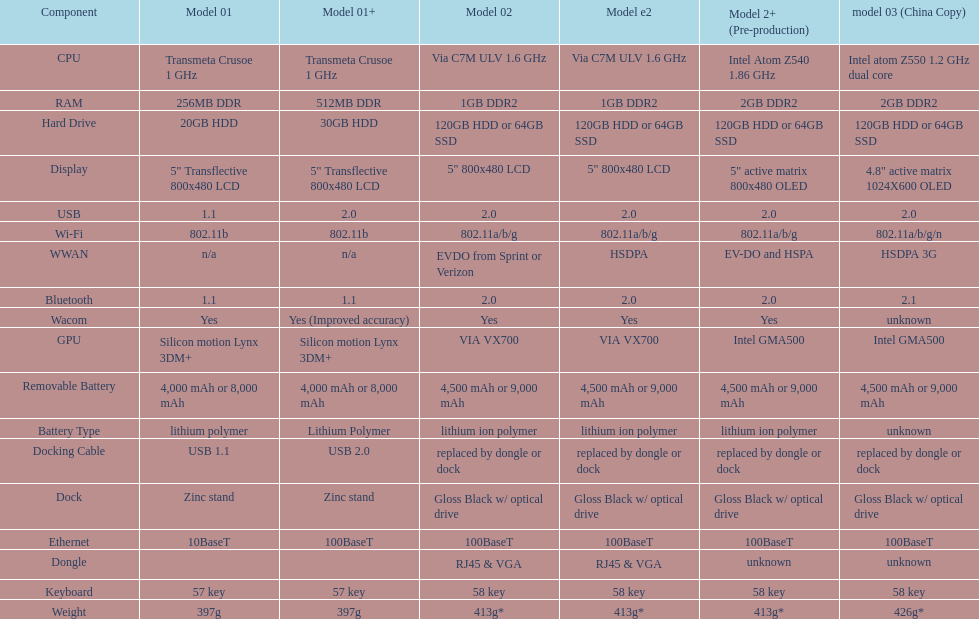What's the mean number of models possessing usb 5. 